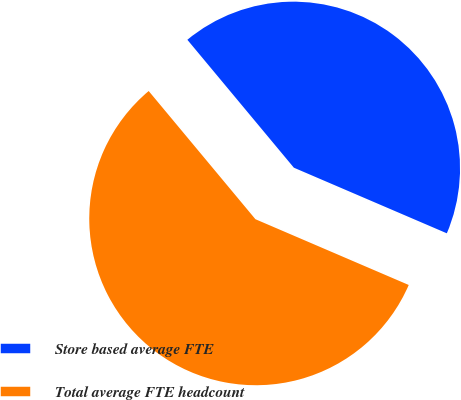<chart> <loc_0><loc_0><loc_500><loc_500><pie_chart><fcel>Store based average FTE<fcel>Total average FTE headcount<nl><fcel>42.5%<fcel>57.5%<nl></chart> 